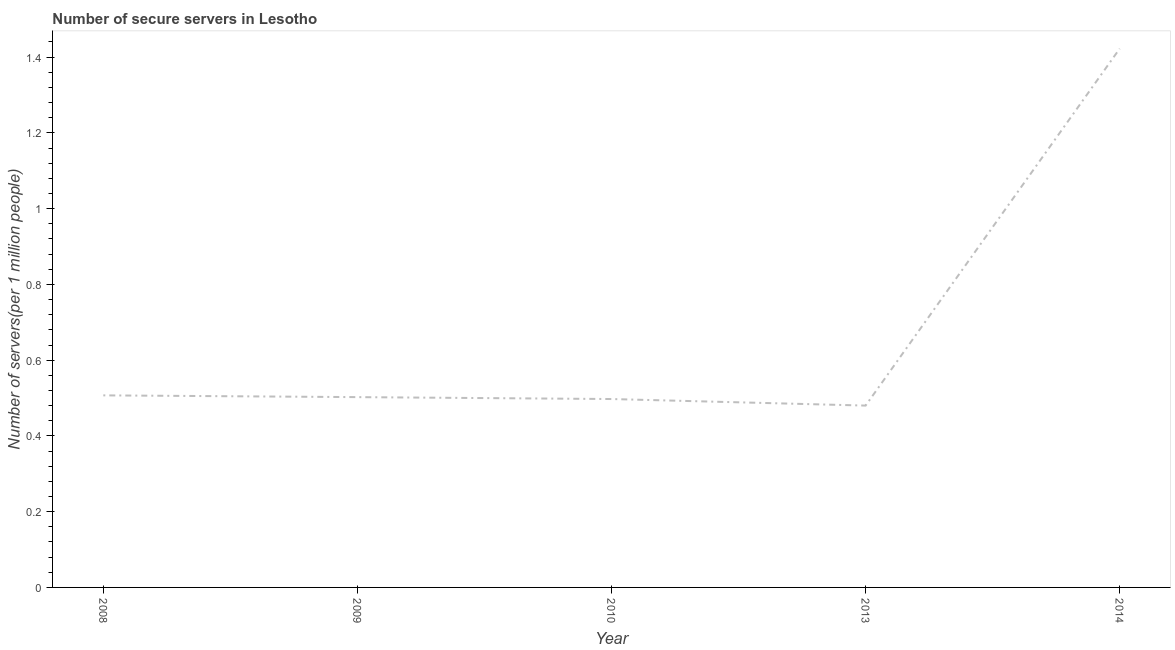What is the number of secure internet servers in 2009?
Offer a very short reply. 0.5. Across all years, what is the maximum number of secure internet servers?
Give a very brief answer. 1.42. Across all years, what is the minimum number of secure internet servers?
Give a very brief answer. 0.48. In which year was the number of secure internet servers maximum?
Ensure brevity in your answer.  2014. In which year was the number of secure internet servers minimum?
Provide a short and direct response. 2013. What is the sum of the number of secure internet servers?
Offer a very short reply. 3.41. What is the difference between the number of secure internet servers in 2008 and 2009?
Offer a terse response. 0. What is the average number of secure internet servers per year?
Provide a succinct answer. 0.68. What is the median number of secure internet servers?
Your answer should be compact. 0.5. Do a majority of the years between 2013 and 2014 (inclusive) have number of secure internet servers greater than 0.6000000000000001 ?
Offer a very short reply. No. What is the ratio of the number of secure internet servers in 2009 to that in 2010?
Your answer should be compact. 1.01. Is the number of secure internet servers in 2009 less than that in 2014?
Your answer should be very brief. Yes. Is the difference between the number of secure internet servers in 2008 and 2014 greater than the difference between any two years?
Keep it short and to the point. No. What is the difference between the highest and the second highest number of secure internet servers?
Your answer should be very brief. 0.92. Is the sum of the number of secure internet servers in 2009 and 2010 greater than the maximum number of secure internet servers across all years?
Make the answer very short. No. What is the difference between the highest and the lowest number of secure internet servers?
Provide a succinct answer. 0.94. What is the difference between two consecutive major ticks on the Y-axis?
Keep it short and to the point. 0.2. Does the graph contain any zero values?
Offer a terse response. No. What is the title of the graph?
Offer a very short reply. Number of secure servers in Lesotho. What is the label or title of the X-axis?
Keep it short and to the point. Year. What is the label or title of the Y-axis?
Offer a terse response. Number of servers(per 1 million people). What is the Number of servers(per 1 million people) in 2008?
Offer a very short reply. 0.51. What is the Number of servers(per 1 million people) of 2009?
Your answer should be compact. 0.5. What is the Number of servers(per 1 million people) of 2010?
Your response must be concise. 0.5. What is the Number of servers(per 1 million people) in 2013?
Ensure brevity in your answer.  0.48. What is the Number of servers(per 1 million people) of 2014?
Offer a very short reply. 1.42. What is the difference between the Number of servers(per 1 million people) in 2008 and 2009?
Your answer should be very brief. 0. What is the difference between the Number of servers(per 1 million people) in 2008 and 2010?
Provide a short and direct response. 0.01. What is the difference between the Number of servers(per 1 million people) in 2008 and 2013?
Provide a succinct answer. 0.03. What is the difference between the Number of servers(per 1 million people) in 2008 and 2014?
Make the answer very short. -0.92. What is the difference between the Number of servers(per 1 million people) in 2009 and 2010?
Provide a succinct answer. 0.01. What is the difference between the Number of servers(per 1 million people) in 2009 and 2013?
Your answer should be compact. 0.02. What is the difference between the Number of servers(per 1 million people) in 2009 and 2014?
Offer a terse response. -0.92. What is the difference between the Number of servers(per 1 million people) in 2010 and 2013?
Offer a terse response. 0.02. What is the difference between the Number of servers(per 1 million people) in 2010 and 2014?
Your answer should be very brief. -0.92. What is the difference between the Number of servers(per 1 million people) in 2013 and 2014?
Make the answer very short. -0.94. What is the ratio of the Number of servers(per 1 million people) in 2008 to that in 2009?
Your answer should be compact. 1.01. What is the ratio of the Number of servers(per 1 million people) in 2008 to that in 2013?
Provide a short and direct response. 1.06. What is the ratio of the Number of servers(per 1 million people) in 2008 to that in 2014?
Your answer should be very brief. 0.36. What is the ratio of the Number of servers(per 1 million people) in 2009 to that in 2013?
Give a very brief answer. 1.05. What is the ratio of the Number of servers(per 1 million people) in 2009 to that in 2014?
Your answer should be compact. 0.35. What is the ratio of the Number of servers(per 1 million people) in 2010 to that in 2013?
Give a very brief answer. 1.04. What is the ratio of the Number of servers(per 1 million people) in 2010 to that in 2014?
Ensure brevity in your answer.  0.35. What is the ratio of the Number of servers(per 1 million people) in 2013 to that in 2014?
Offer a terse response. 0.34. 